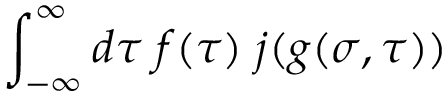<formula> <loc_0><loc_0><loc_500><loc_500>\int _ { - \infty } ^ { \infty } d \tau \, f ( \tau ) \, j ( g ( \sigma , \tau ) )</formula> 